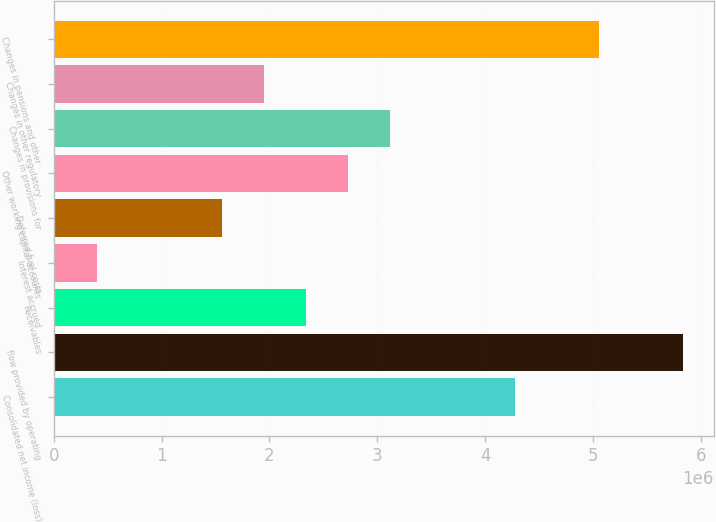Convert chart to OTSL. <chart><loc_0><loc_0><loc_500><loc_500><bar_chart><fcel>Consolidated net income (loss)<fcel>flow provided by operating<fcel>Receivables<fcel>Interest accrued<fcel>Deferred fuel costs<fcel>Other working capital accounts<fcel>Changes in provisions for<fcel>Changes in other regulatory<fcel>Changes in pensions and other<nl><fcel>4.27751e+06<fcel>5.82929e+06<fcel>2.33778e+06<fcel>398046<fcel>1.56188e+06<fcel>2.72572e+06<fcel>3.11367e+06<fcel>1.94983e+06<fcel>5.0534e+06<nl></chart> 